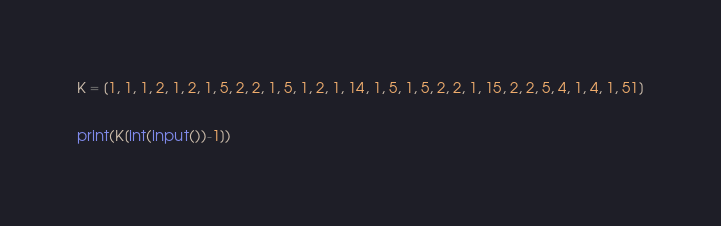Convert code to text. <code><loc_0><loc_0><loc_500><loc_500><_Python_>K = [1, 1, 1, 2, 1, 2, 1, 5, 2, 2, 1, 5, 1, 2, 1, 14, 1, 5, 1, 5, 2, 2, 1, 15, 2, 2, 5, 4, 1, 4, 1, 51]

print(K[int(input())-1])</code> 